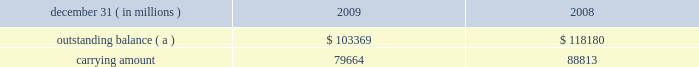Notes to consolidated financial statements jpmorgan chase & co./2009 annual report 204 on the amount of interest income recognized in the firm 2019s consolidated statements of income since that date .
( b ) other changes in expected cash flows include the net impact of changes in esti- mated prepayments and reclassifications to the nonaccretable difference .
On a quarterly basis , the firm updates the amount of loan principal and interest cash flows expected to be collected , incorporating assumptions regarding default rates , loss severities , the amounts and timing of prepayments and other factors that are reflective of current market conditions .
Probable decreases in expected loan principal cash flows trigger the recognition of impairment , which is then measured as the present value of the expected principal loss plus any related foregone interest cash flows discounted at the pool 2019s effective interest rate .
Impairments that occur after the acquisition date are recognized through the provision and allow- ance for loan losses .
Probable and significant increases in expected principal cash flows would first reverse any previously recorded allowance for loan losses ; any remaining increases are recognized prospectively as interest income .
The impacts of ( i ) prepayments , ( ii ) changes in variable interest rates , and ( iii ) any other changes in the timing of expected cash flows are recognized prospectively as adjustments to interest income .
Disposals of loans , which may include sales of loans , receipt of payments in full by the borrower , or foreclosure , result in removal of the loan from the purchased credit-impaired portfolio .
If the timing and/or amounts of expected cash flows on these purchased credit-impaired loans were determined not to be rea- sonably estimable , no interest would be accreted and the loans would be reported as nonperforming loans ; however , since the timing and amounts of expected cash flows for these purchased credit-impaired loans are reasonably estimable , interest is being accreted and the loans are being reported as performing loans .
Charge-offs are not recorded on purchased credit-impaired loans until actual losses exceed the estimated losses that were recorded as purchase accounting adjustments at acquisition date .
To date , no charge-offs have been recorded for these loans .
Purchased credit-impaired loans acquired in the washington mu- tual transaction are reported in loans on the firm 2019s consolidated balance sheets .
In 2009 , an allowance for loan losses of $ 1.6 billion was recorded for the prime mortgage and option arm pools of loans .
The net aggregate carrying amount of the pools that have an allowance for loan losses was $ 47.2 billion at december 31 , 2009 .
This allowance for loan losses is reported as a reduction of the carrying amount of the loans in the table below .
The table below provides additional information about these pur- chased credit-impaired consumer loans. .
( a ) represents the sum of contractual principal , interest and fees earned at the reporting date .
Purchased credit-impaired loans are also being modified under the mha programs and the firm 2019s other loss mitigation programs .
For these loans , the impact of the modification is incorporated into the firm 2019s quarterly assessment of whether a probable and/or signifi- cant change in estimated future cash flows has occurred , and the loans continue to be accounted for as and reported as purchased credit-impaired loans .
Foreclosed property the firm acquires property from borrowers through loan restructur- ings , workouts , and foreclosures , which is recorded in other assets on the consolidated balance sheets .
Property acquired may include real property ( e.g. , land , buildings , and fixtures ) and commercial and personal property ( e.g. , aircraft , railcars , and ships ) .
Acquired property is valued at fair value less costs to sell at acquisition .
Each quarter the fair value of the acquired property is reviewed and adjusted , if necessary .
Any adjustments to fair value in the first 90 days are charged to the allowance for loan losses and thereafter adjustments are charged/credited to noninterest revenue 2013other .
Operating expense , such as real estate taxes and maintenance , are charged to other expense .
Note 14 2013 allowance for credit losses the allowance for loan losses includes an asset-specific component , a formula-based component and a component related to purchased credit-impaired loans .
The asset-specific component relates to loans considered to be impaired , which includes any loans that have been modified in a troubled debt restructuring as well as risk-rated loans that have been placed on nonaccrual status .
An asset-specific allowance for impaired loans is established when the loan 2019s discounted cash flows ( or , when available , the loan 2019s observable market price ) is lower than the recorded investment in the loan .
To compute the asset-specific component of the allowance , larger loans are evaluated individually , while smaller loans are evaluated as pools using historical loss experience for the respective class of assets .
Risk-rated loans ( primarily wholesale loans ) are pooled by risk rating , while scored loans ( i.e. , consumer loans ) are pooled by product type .
The firm generally measures the asset-specific allowance as the difference between the recorded investment in the loan and the present value of the cash flows expected to be collected , dis- counted at the loan 2019s original effective interest rate .
Subsequent changes in measured impairment due to the impact of discounting are reported as an adjustment to the provision for loan losses , not as an adjustment to interest income .
An asset-specific allowance for an impaired loan with an observable market price is measured as the difference between the recorded investment in the loan and the loan 2019s fair value .
Certain impaired loans that are determined to be collateral- dependent are charged-off to the fair value of the collateral less costs to sell .
When collateral-dependent commercial real-estate loans are determined to be impaired , updated appraisals are typi- cally obtained and updated every six to twelve months .
The firm also considers both borrower- and market-specific factors , which .
What was the percent of the pur- chased credit-impaired consumer loans carrying amount to the outstanding balance? 
Computations: (79664 / 103369)
Answer: 0.77068. 